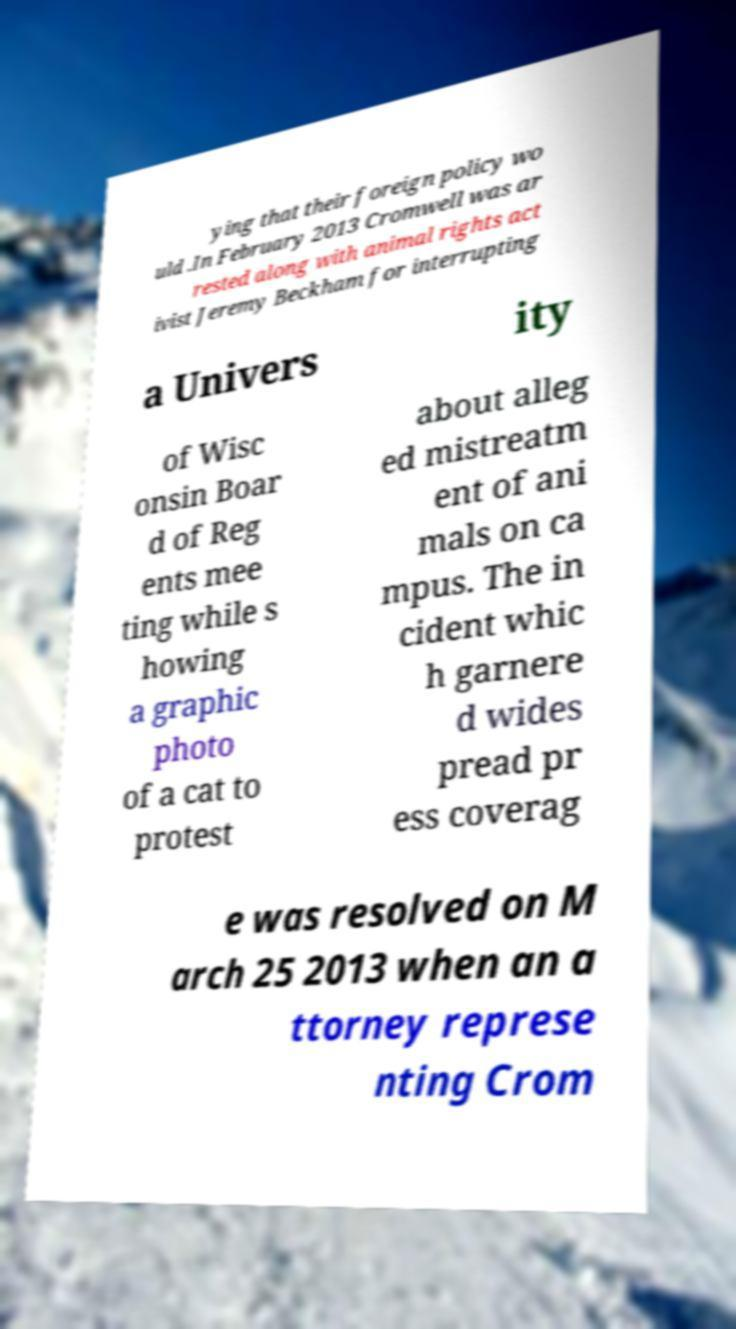For documentation purposes, I need the text within this image transcribed. Could you provide that? ying that their foreign policy wo uld .In February 2013 Cromwell was ar rested along with animal rights act ivist Jeremy Beckham for interrupting a Univers ity of Wisc onsin Boar d of Reg ents mee ting while s howing a graphic photo of a cat to protest about alleg ed mistreatm ent of ani mals on ca mpus. The in cident whic h garnere d wides pread pr ess coverag e was resolved on M arch 25 2013 when an a ttorney represe nting Crom 